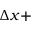Convert formula to latex. <formula><loc_0><loc_0><loc_500><loc_500>\Delta x +</formula> 